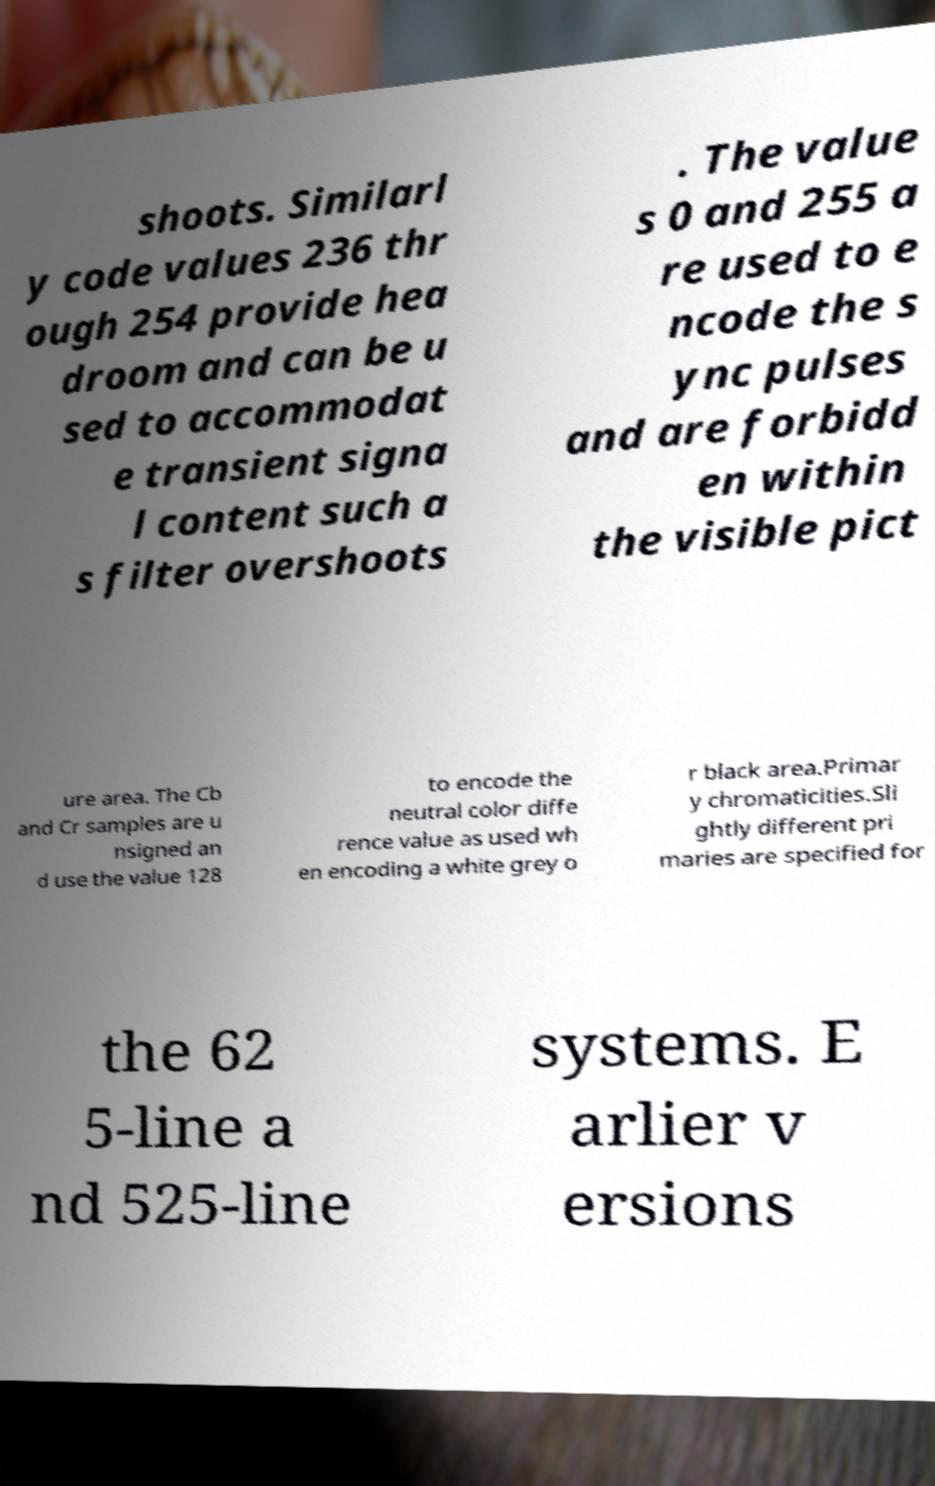There's text embedded in this image that I need extracted. Can you transcribe it verbatim? shoots. Similarl y code values 236 thr ough 254 provide hea droom and can be u sed to accommodat e transient signa l content such a s filter overshoots . The value s 0 and 255 a re used to e ncode the s ync pulses and are forbidd en within the visible pict ure area. The Cb and Cr samples are u nsigned an d use the value 128 to encode the neutral color diffe rence value as used wh en encoding a white grey o r black area.Primar y chromaticities.Sli ghtly different pri maries are specified for the 62 5-line a nd 525-line systems. E arlier v ersions 